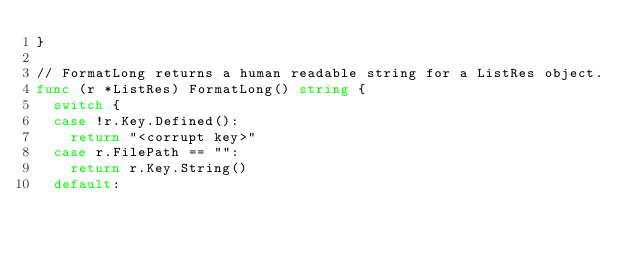<code> <loc_0><loc_0><loc_500><loc_500><_Go_>}

// FormatLong returns a human readable string for a ListRes object.
func (r *ListRes) FormatLong() string {
	switch {
	case !r.Key.Defined():
		return "<corrupt key>"
	case r.FilePath == "":
		return r.Key.String()
	default:</code> 